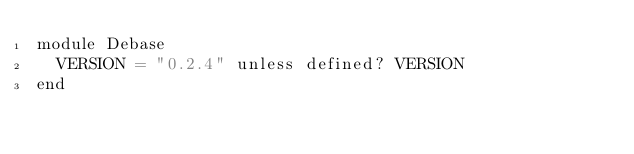<code> <loc_0><loc_0><loc_500><loc_500><_Ruby_>module Debase
  VERSION = "0.2.4" unless defined? VERSION
end
</code> 